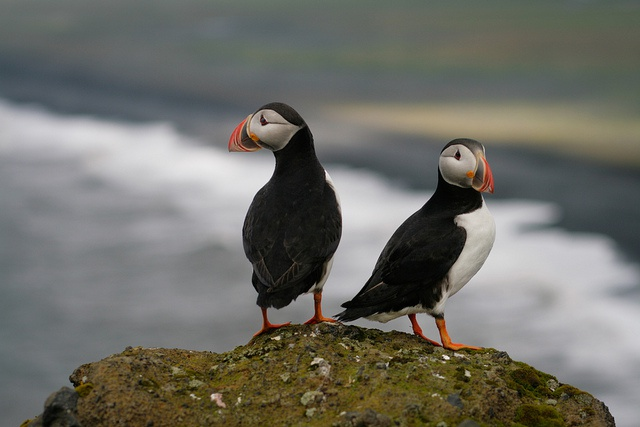Describe the objects in this image and their specific colors. I can see bird in gray, black, darkgray, and lightgray tones and bird in gray, black, darkgray, and maroon tones in this image. 